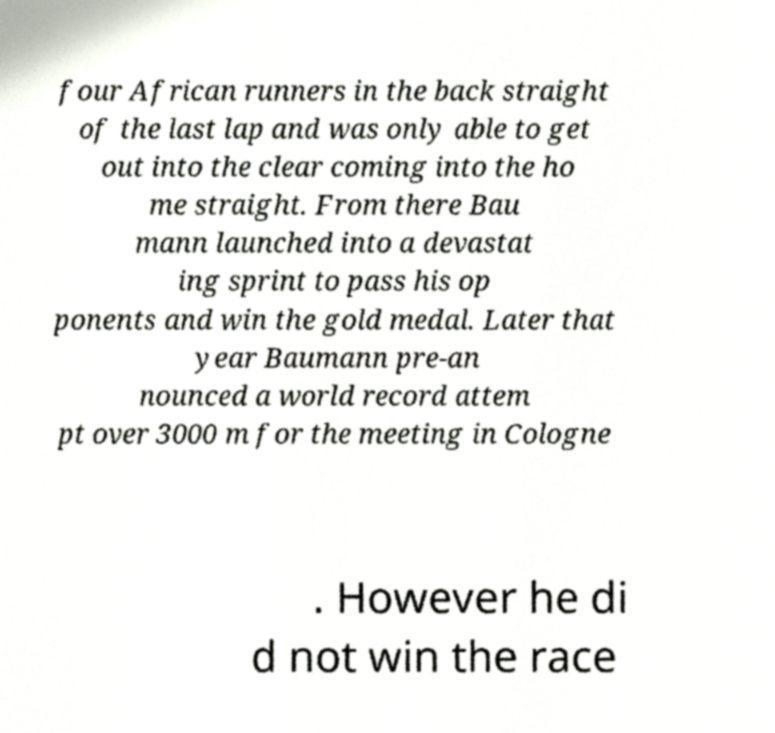Could you assist in decoding the text presented in this image and type it out clearly? four African runners in the back straight of the last lap and was only able to get out into the clear coming into the ho me straight. From there Bau mann launched into a devastat ing sprint to pass his op ponents and win the gold medal. Later that year Baumann pre-an nounced a world record attem pt over 3000 m for the meeting in Cologne . However he di d not win the race 